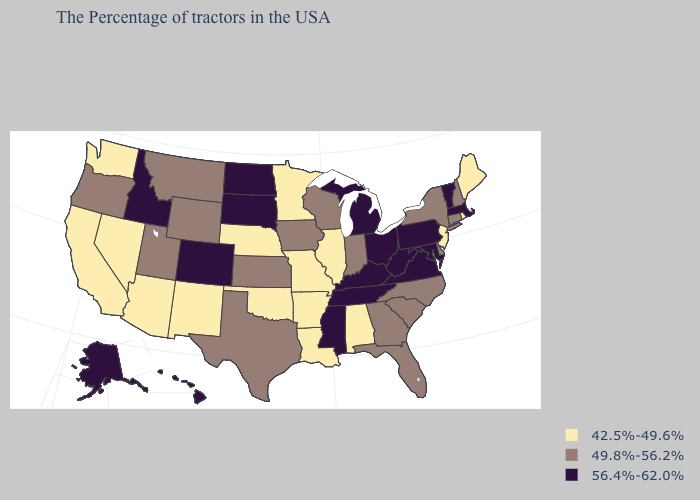Among the states that border Arizona , does Colorado have the lowest value?
Answer briefly. No. Name the states that have a value in the range 42.5%-49.6%?
Write a very short answer. Maine, Rhode Island, New Jersey, Alabama, Illinois, Louisiana, Missouri, Arkansas, Minnesota, Nebraska, Oklahoma, New Mexico, Arizona, Nevada, California, Washington. Which states have the highest value in the USA?
Write a very short answer. Massachusetts, Vermont, Maryland, Pennsylvania, Virginia, West Virginia, Ohio, Michigan, Kentucky, Tennessee, Mississippi, South Dakota, North Dakota, Colorado, Idaho, Alaska, Hawaii. Among the states that border Alabama , which have the highest value?
Concise answer only. Tennessee, Mississippi. Name the states that have a value in the range 42.5%-49.6%?
Write a very short answer. Maine, Rhode Island, New Jersey, Alabama, Illinois, Louisiana, Missouri, Arkansas, Minnesota, Nebraska, Oklahoma, New Mexico, Arizona, Nevada, California, Washington. What is the value of Oregon?
Be succinct. 49.8%-56.2%. What is the value of Massachusetts?
Be succinct. 56.4%-62.0%. What is the highest value in states that border Nevada?
Keep it brief. 56.4%-62.0%. Which states have the lowest value in the USA?
Keep it brief. Maine, Rhode Island, New Jersey, Alabama, Illinois, Louisiana, Missouri, Arkansas, Minnesota, Nebraska, Oklahoma, New Mexico, Arizona, Nevada, California, Washington. What is the lowest value in the South?
Write a very short answer. 42.5%-49.6%. What is the value of Georgia?
Give a very brief answer. 49.8%-56.2%. What is the value of Colorado?
Write a very short answer. 56.4%-62.0%. What is the lowest value in the USA?
Be succinct. 42.5%-49.6%. What is the value of Kansas?
Write a very short answer. 49.8%-56.2%. Does Virginia have the same value as Colorado?
Be succinct. Yes. 